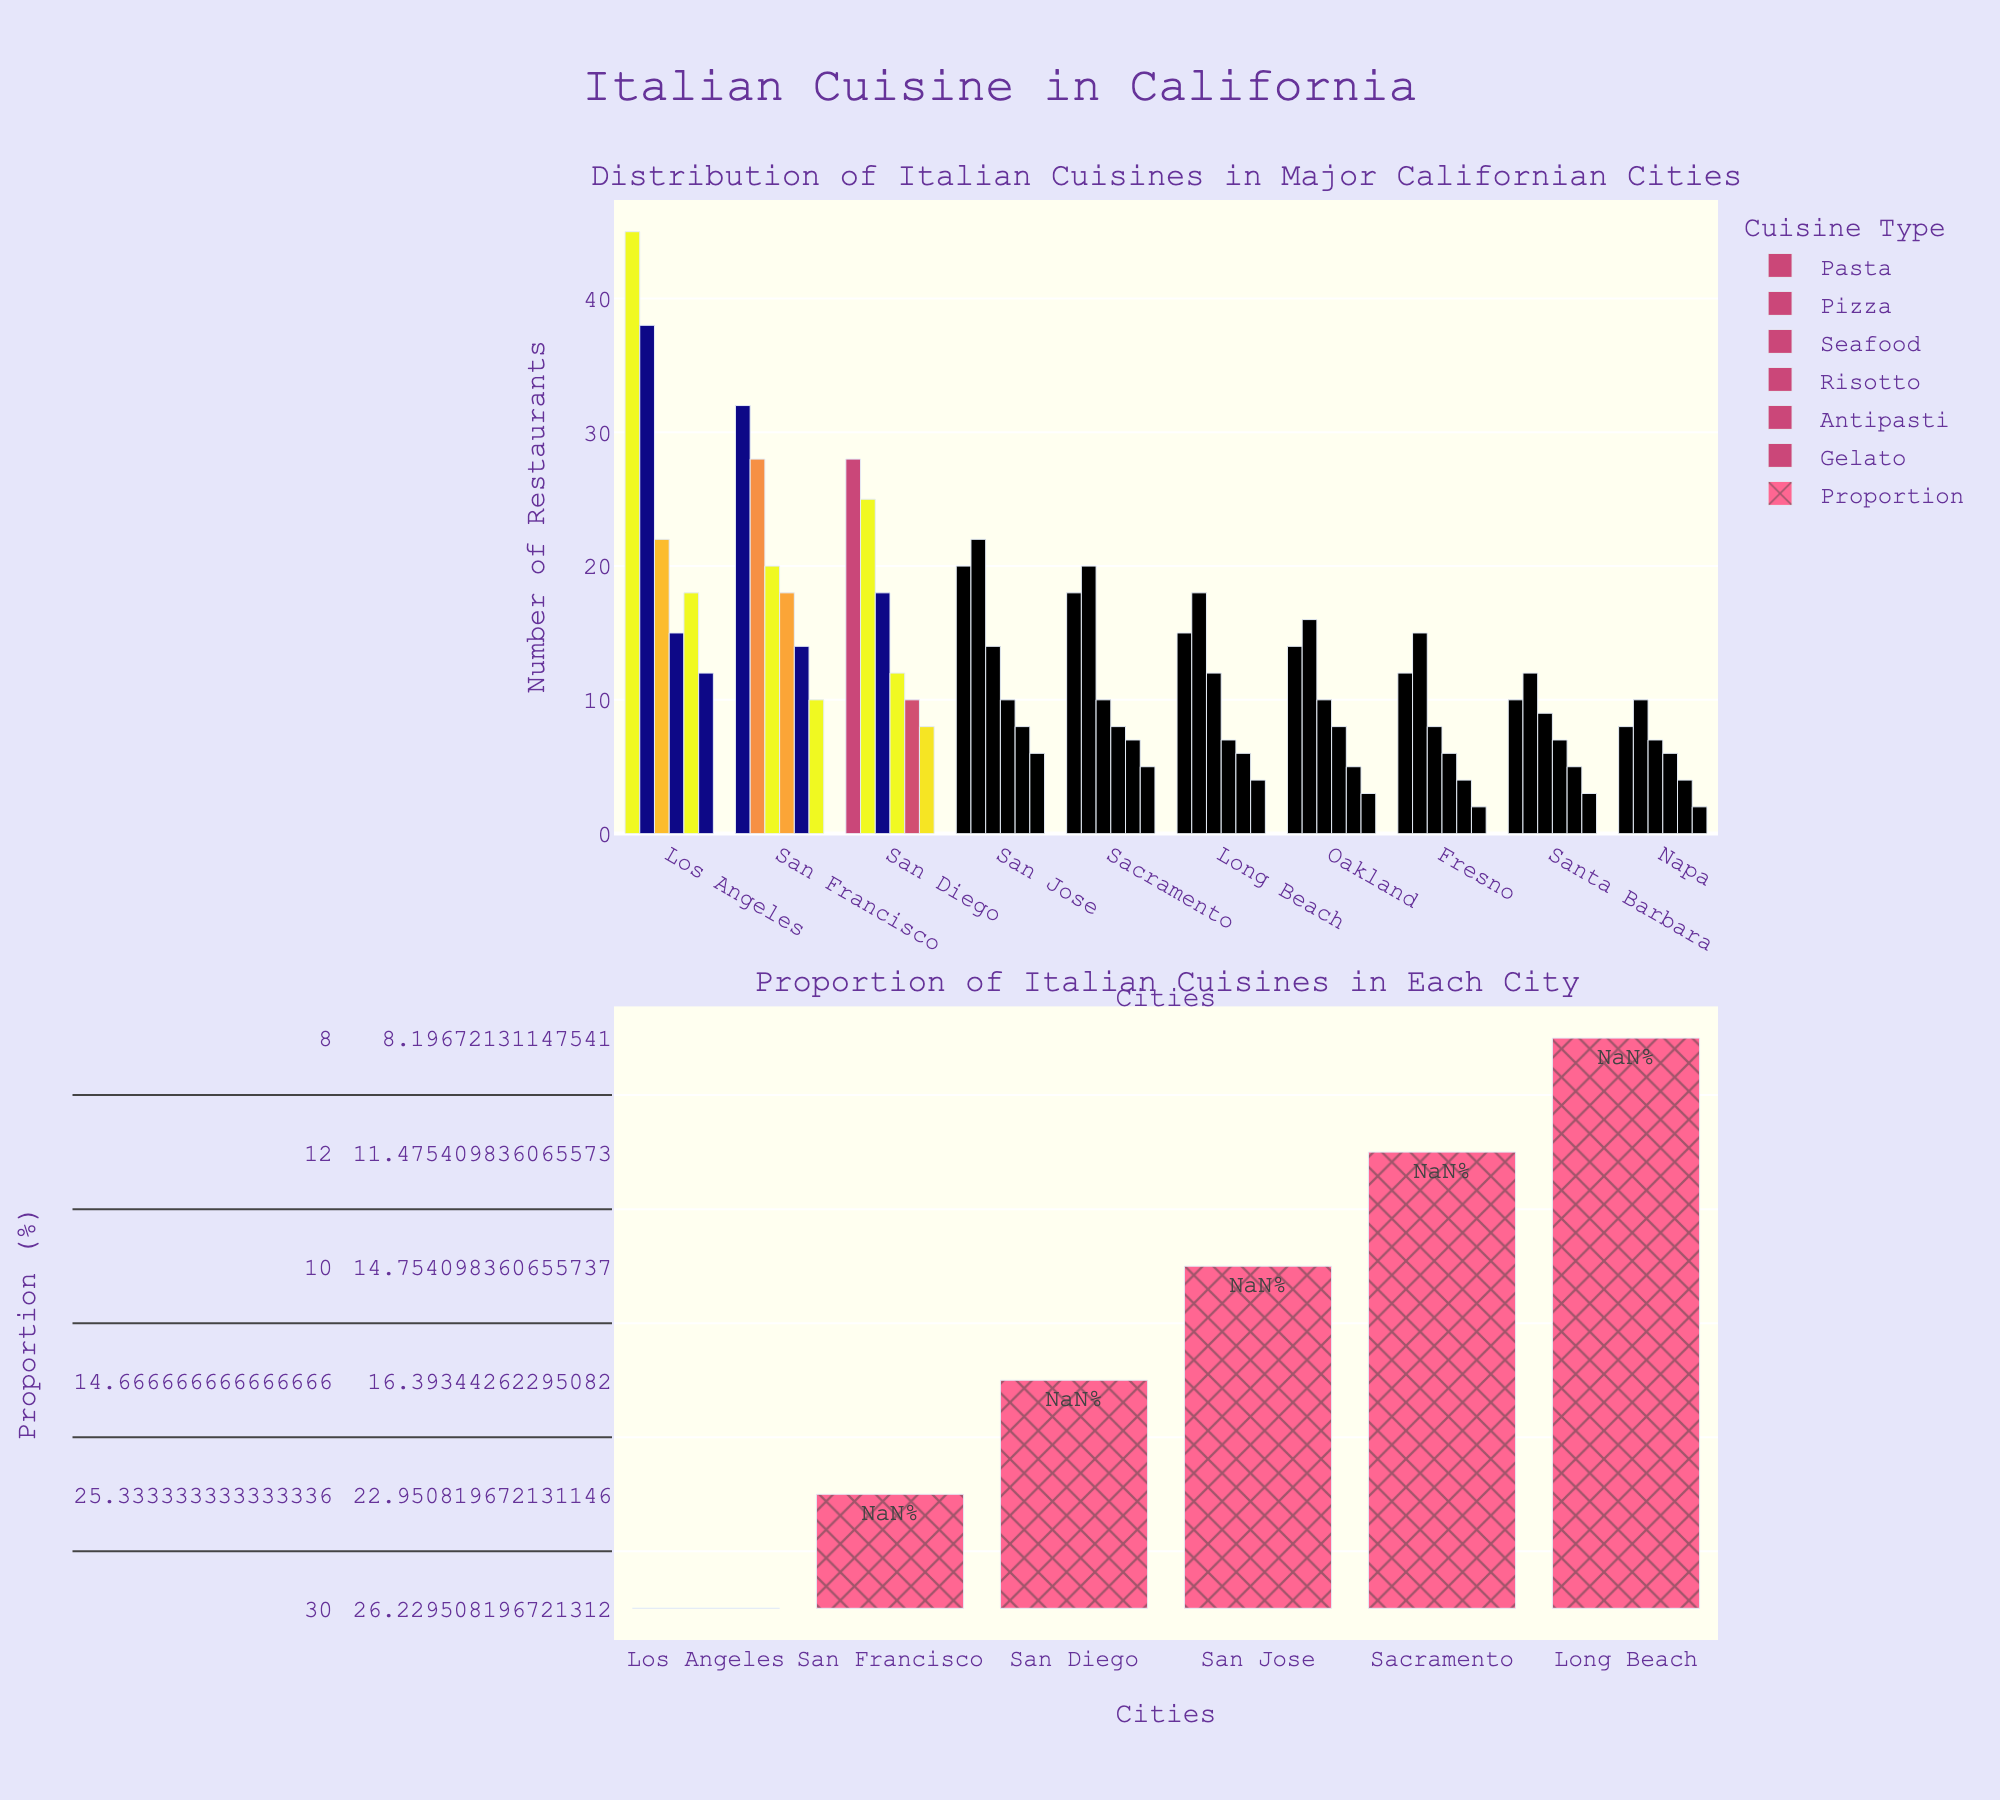Which city has the highest number of Pasta restaurants? According to the top bar chart, the city with the highest number of Pasta restaurants is Los Angeles, with a visible higher bar length than the other cities.
Answer: Los Angeles How many more Pizza restaurants are there in Los Angeles compared to San Francisco? The number of Pizza restaurants in Los Angeles is 38, whereas in San Francisco, it is 28. The difference is calculated as 38 - 28.
Answer: 10 Which city has the lowest number of Gelato shops? From the top bar chart, Napa displays the shortest bar length for Gelato shops among all cities, with 2 Gelato shops listed.
Answer: Napa Compare the number of Risotto restaurants in San Diego and Sacramento. Which city has more? In the top bar chart, San Diego has a bar of height 12 for Risotto restaurants, while Sacramento's bar height is 8. Hence, San Diego has more Risotto restaurants.
Answer: San Diego What is the total number of Antipasti restaurants in Fresno, Santa Barbara, and Napa combined? The number of Antipasti restaurants is 4 in Fresno, 5 in Santa Barbara, and 4 in Napa. Summing them up gives 4 + 5 + 4 = 13.
Answer: 13 What proportion of Italian restaurants in San Jose are Gelato shops? In the bottom bar chart, the proportion of Gelato shops in San Jose can be found by taking the number of Gelato shops (6) and dividing it by the total number of Italian restaurants, then converting to a percentage. Total Italian restaurants in San Jose are 80 (summation of all cuisine types). The proportion is (6/80)*100 = 7.5%.
Answer: 7.5% Is the number of Seafood restaurants greater in Oakland or Long Beach? Referring to the top bar chart, Oakland has 10 Seafood restaurants, and Long Beach also has a bar height reflecting 12 Seafood restaurants. Therefore, Long Beach has more Seafood restaurants.
Answer: Long Beach Which city has the most balanced distribution of Italian cuisine types? Observing the bottom bar chart for proportional distribution, San Francisco seems to have the most balanced distribution, as the bars indicating proportions are relatively even across different cuisine types. In contrast, other cities show more skewed distributions.
Answer: San Francisco 